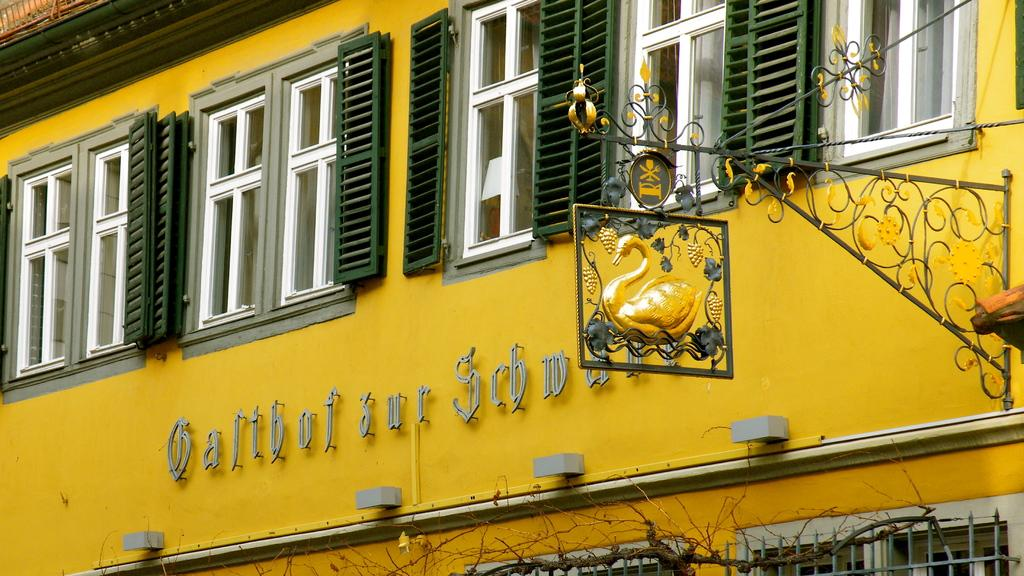What is the color of the building in the image? The building in the image is yellow. What color are the windows on the building? The windows on the building are white. What type of vegetation can be seen in the image? There are dried trees in the image. What is attached to the wall of the building? There is a board fixed to the wall in the image. How many geese are flying over the building in the image? There are no geese present in the image; it only features a yellow building with white windows, dried trees, and a board fixed to the wall. What fact can be learned about the building's construction from the image? The image does not provide any information about the building's construction, only its color, window color, and the presence of a board on the wall. 